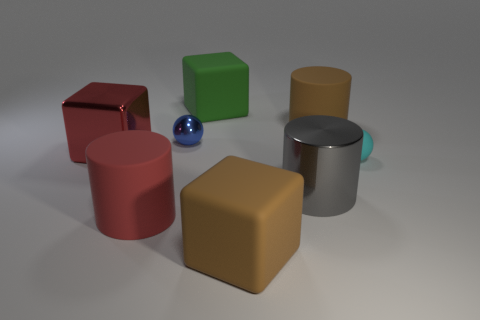Is the size of the red metallic thing the same as the gray cylinder?
Give a very brief answer. Yes. How many matte objects are tiny cyan spheres or big blocks?
Offer a very short reply. 3. What material is the red block that is the same size as the brown block?
Offer a very short reply. Metal. How many other things are the same material as the green block?
Provide a succinct answer. 4. Is the number of cylinders behind the green matte cube less than the number of large cyan rubber cylinders?
Your response must be concise. No. Is the big red matte object the same shape as the tiny blue metal object?
Provide a short and direct response. No. What is the size of the brown cube left of the metal object on the right side of the big brown thing that is in front of the big brown rubber cylinder?
Provide a succinct answer. Large. There is a tiny blue thing that is the same shape as the cyan thing; what is it made of?
Give a very brief answer. Metal. Is there any other thing that is the same size as the brown block?
Provide a succinct answer. Yes. What is the size of the matte block behind the small ball that is on the right side of the blue ball?
Offer a terse response. Large. 